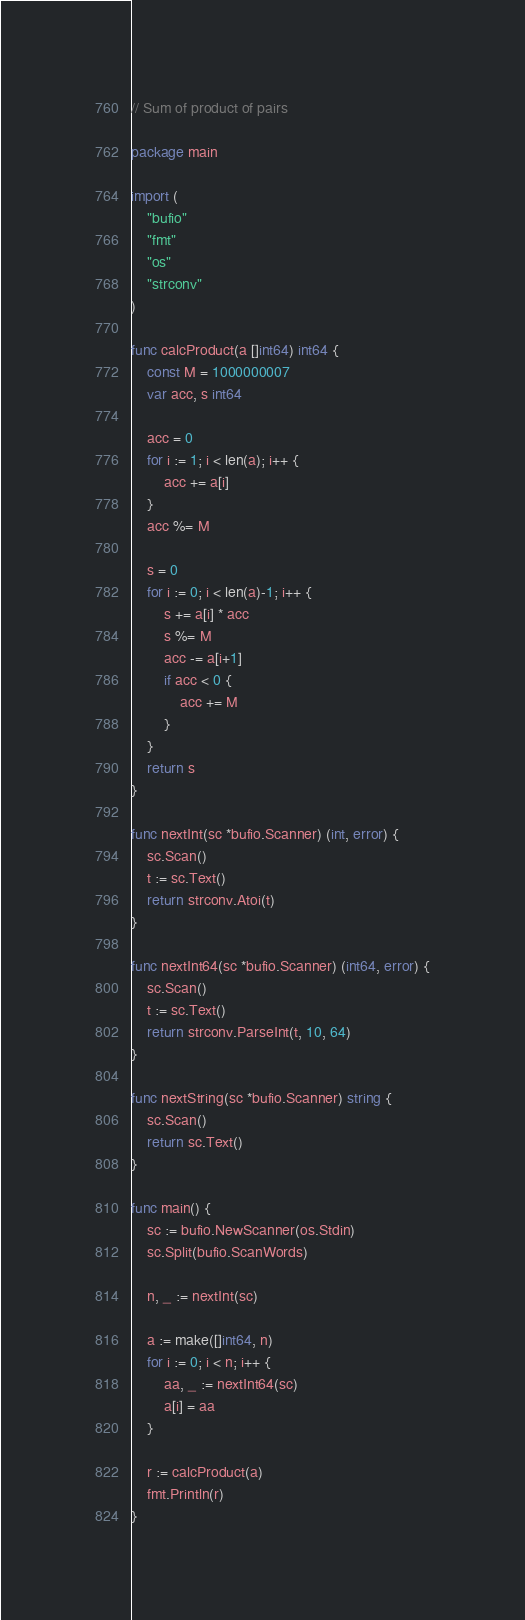<code> <loc_0><loc_0><loc_500><loc_500><_Go_>// Sum of product of pairs

package main

import (
	"bufio"
	"fmt"
	"os"
	"strconv"
)

func calcProduct(a []int64) int64 {
	const M = 1000000007
	var acc, s int64

	acc = 0
	for i := 1; i < len(a); i++ {
		acc += a[i]
	}
	acc %= M

	s = 0
	for i := 0; i < len(a)-1; i++ {
		s += a[i] * acc
		s %= M
		acc -= a[i+1]
		if acc < 0 {
			acc += M
		}
	}
	return s
}

func nextInt(sc *bufio.Scanner) (int, error) {
	sc.Scan()
	t := sc.Text()
	return strconv.Atoi(t)
}

func nextInt64(sc *bufio.Scanner) (int64, error) {
	sc.Scan()
	t := sc.Text()
	return strconv.ParseInt(t, 10, 64)
}

func nextString(sc *bufio.Scanner) string {
	sc.Scan()
	return sc.Text()
}

func main() {
	sc := bufio.NewScanner(os.Stdin)
	sc.Split(bufio.ScanWords)

	n, _ := nextInt(sc)

	a := make([]int64, n)
	for i := 0; i < n; i++ {
		aa, _ := nextInt64(sc)
		a[i] = aa
	}

	r := calcProduct(a)
	fmt.Println(r)
}
</code> 